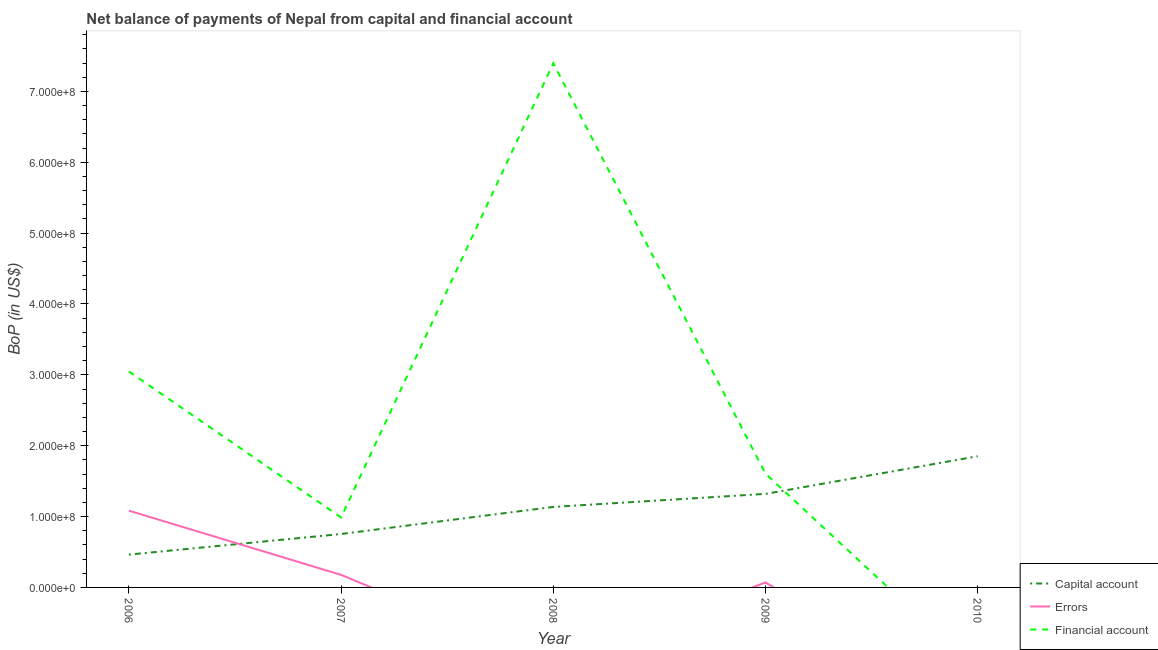What is the amount of errors in 2006?
Your answer should be very brief. 1.08e+08. Across all years, what is the maximum amount of net capital account?
Ensure brevity in your answer.  1.85e+08. Across all years, what is the minimum amount of errors?
Make the answer very short. 0. What is the total amount of net capital account in the graph?
Make the answer very short. 5.52e+08. What is the difference between the amount of financial account in 2006 and that in 2009?
Give a very brief answer. 1.44e+08. What is the difference between the amount of financial account in 2007 and the amount of errors in 2006?
Offer a terse response. -9.59e+06. What is the average amount of financial account per year?
Keep it short and to the point. 2.61e+08. In the year 2009, what is the difference between the amount of net capital account and amount of errors?
Your answer should be very brief. 1.25e+08. In how many years, is the amount of net capital account greater than 280000000 US$?
Offer a terse response. 0. What is the ratio of the amount of financial account in 2006 to that in 2008?
Make the answer very short. 0.41. Is the difference between the amount of financial account in 2006 and 2008 greater than the difference between the amount of net capital account in 2006 and 2008?
Keep it short and to the point. No. What is the difference between the highest and the second highest amount of net capital account?
Your response must be concise. 5.31e+07. What is the difference between the highest and the lowest amount of net capital account?
Provide a succinct answer. 1.39e+08. Is it the case that in every year, the sum of the amount of net capital account and amount of errors is greater than the amount of financial account?
Give a very brief answer. No. Is the amount of net capital account strictly greater than the amount of errors over the years?
Give a very brief answer. No. How many lines are there?
Your answer should be very brief. 3. What is the difference between two consecutive major ticks on the Y-axis?
Offer a very short reply. 1.00e+08. Are the values on the major ticks of Y-axis written in scientific E-notation?
Keep it short and to the point. Yes. Does the graph contain grids?
Offer a very short reply. No. How are the legend labels stacked?
Provide a succinct answer. Vertical. What is the title of the graph?
Your response must be concise. Net balance of payments of Nepal from capital and financial account. Does "Industrial Nitrous Oxide" appear as one of the legend labels in the graph?
Ensure brevity in your answer.  No. What is the label or title of the X-axis?
Offer a very short reply. Year. What is the label or title of the Y-axis?
Provide a succinct answer. BoP (in US$). What is the BoP (in US$) in Capital account in 2006?
Your answer should be compact. 4.63e+07. What is the BoP (in US$) in Errors in 2006?
Ensure brevity in your answer.  1.08e+08. What is the BoP (in US$) in Financial account in 2006?
Your response must be concise. 3.05e+08. What is the BoP (in US$) in Capital account in 2007?
Your response must be concise. 7.54e+07. What is the BoP (in US$) of Errors in 2007?
Offer a terse response. 1.77e+07. What is the BoP (in US$) of Financial account in 2007?
Your answer should be compact. 9.88e+07. What is the BoP (in US$) of Capital account in 2008?
Provide a short and direct response. 1.14e+08. What is the BoP (in US$) of Errors in 2008?
Your answer should be compact. 0. What is the BoP (in US$) in Financial account in 2008?
Make the answer very short. 7.40e+08. What is the BoP (in US$) of Capital account in 2009?
Keep it short and to the point. 1.32e+08. What is the BoP (in US$) in Errors in 2009?
Offer a terse response. 7.03e+06. What is the BoP (in US$) in Financial account in 2009?
Your answer should be very brief. 1.60e+08. What is the BoP (in US$) in Capital account in 2010?
Keep it short and to the point. 1.85e+08. What is the BoP (in US$) in Errors in 2010?
Offer a terse response. 0. What is the BoP (in US$) in Financial account in 2010?
Ensure brevity in your answer.  0. Across all years, what is the maximum BoP (in US$) of Capital account?
Your answer should be very brief. 1.85e+08. Across all years, what is the maximum BoP (in US$) in Errors?
Your answer should be very brief. 1.08e+08. Across all years, what is the maximum BoP (in US$) in Financial account?
Offer a terse response. 7.40e+08. Across all years, what is the minimum BoP (in US$) of Capital account?
Keep it short and to the point. 4.63e+07. Across all years, what is the minimum BoP (in US$) in Financial account?
Your response must be concise. 0. What is the total BoP (in US$) in Capital account in the graph?
Give a very brief answer. 5.52e+08. What is the total BoP (in US$) in Errors in the graph?
Provide a succinct answer. 1.33e+08. What is the total BoP (in US$) of Financial account in the graph?
Your answer should be very brief. 1.30e+09. What is the difference between the BoP (in US$) of Capital account in 2006 and that in 2007?
Provide a short and direct response. -2.91e+07. What is the difference between the BoP (in US$) in Errors in 2006 and that in 2007?
Give a very brief answer. 9.06e+07. What is the difference between the BoP (in US$) in Financial account in 2006 and that in 2007?
Your answer should be compact. 2.06e+08. What is the difference between the BoP (in US$) of Capital account in 2006 and that in 2008?
Your answer should be very brief. -6.73e+07. What is the difference between the BoP (in US$) of Financial account in 2006 and that in 2008?
Your answer should be compact. -4.35e+08. What is the difference between the BoP (in US$) in Capital account in 2006 and that in 2009?
Offer a terse response. -8.57e+07. What is the difference between the BoP (in US$) of Errors in 2006 and that in 2009?
Provide a short and direct response. 1.01e+08. What is the difference between the BoP (in US$) in Financial account in 2006 and that in 2009?
Your answer should be very brief. 1.44e+08. What is the difference between the BoP (in US$) of Capital account in 2006 and that in 2010?
Ensure brevity in your answer.  -1.39e+08. What is the difference between the BoP (in US$) in Capital account in 2007 and that in 2008?
Your response must be concise. -3.82e+07. What is the difference between the BoP (in US$) in Financial account in 2007 and that in 2008?
Offer a very short reply. -6.41e+08. What is the difference between the BoP (in US$) in Capital account in 2007 and that in 2009?
Provide a succinct answer. -5.66e+07. What is the difference between the BoP (in US$) in Errors in 2007 and that in 2009?
Your response must be concise. 1.07e+07. What is the difference between the BoP (in US$) of Financial account in 2007 and that in 2009?
Your answer should be very brief. -6.17e+07. What is the difference between the BoP (in US$) of Capital account in 2007 and that in 2010?
Your answer should be very brief. -1.10e+08. What is the difference between the BoP (in US$) in Capital account in 2008 and that in 2009?
Your answer should be very brief. -1.84e+07. What is the difference between the BoP (in US$) in Financial account in 2008 and that in 2009?
Give a very brief answer. 5.79e+08. What is the difference between the BoP (in US$) in Capital account in 2008 and that in 2010?
Keep it short and to the point. -7.15e+07. What is the difference between the BoP (in US$) in Capital account in 2009 and that in 2010?
Provide a succinct answer. -5.31e+07. What is the difference between the BoP (in US$) of Capital account in 2006 and the BoP (in US$) of Errors in 2007?
Offer a very short reply. 2.86e+07. What is the difference between the BoP (in US$) of Capital account in 2006 and the BoP (in US$) of Financial account in 2007?
Your answer should be very brief. -5.25e+07. What is the difference between the BoP (in US$) of Errors in 2006 and the BoP (in US$) of Financial account in 2007?
Make the answer very short. 9.59e+06. What is the difference between the BoP (in US$) in Capital account in 2006 and the BoP (in US$) in Financial account in 2008?
Give a very brief answer. -6.93e+08. What is the difference between the BoP (in US$) of Errors in 2006 and the BoP (in US$) of Financial account in 2008?
Give a very brief answer. -6.31e+08. What is the difference between the BoP (in US$) of Capital account in 2006 and the BoP (in US$) of Errors in 2009?
Offer a terse response. 3.93e+07. What is the difference between the BoP (in US$) of Capital account in 2006 and the BoP (in US$) of Financial account in 2009?
Ensure brevity in your answer.  -1.14e+08. What is the difference between the BoP (in US$) of Errors in 2006 and the BoP (in US$) of Financial account in 2009?
Provide a succinct answer. -5.21e+07. What is the difference between the BoP (in US$) in Capital account in 2007 and the BoP (in US$) in Financial account in 2008?
Your answer should be compact. -6.64e+08. What is the difference between the BoP (in US$) in Errors in 2007 and the BoP (in US$) in Financial account in 2008?
Provide a short and direct response. -7.22e+08. What is the difference between the BoP (in US$) of Capital account in 2007 and the BoP (in US$) of Errors in 2009?
Your response must be concise. 6.84e+07. What is the difference between the BoP (in US$) of Capital account in 2007 and the BoP (in US$) of Financial account in 2009?
Offer a terse response. -8.51e+07. What is the difference between the BoP (in US$) in Errors in 2007 and the BoP (in US$) in Financial account in 2009?
Ensure brevity in your answer.  -1.43e+08. What is the difference between the BoP (in US$) in Capital account in 2008 and the BoP (in US$) in Errors in 2009?
Your answer should be very brief. 1.07e+08. What is the difference between the BoP (in US$) in Capital account in 2008 and the BoP (in US$) in Financial account in 2009?
Ensure brevity in your answer.  -4.69e+07. What is the average BoP (in US$) in Capital account per year?
Offer a very short reply. 1.10e+08. What is the average BoP (in US$) in Errors per year?
Your answer should be very brief. 2.66e+07. What is the average BoP (in US$) in Financial account per year?
Give a very brief answer. 2.61e+08. In the year 2006, what is the difference between the BoP (in US$) of Capital account and BoP (in US$) of Errors?
Provide a short and direct response. -6.20e+07. In the year 2006, what is the difference between the BoP (in US$) of Capital account and BoP (in US$) of Financial account?
Your answer should be very brief. -2.58e+08. In the year 2006, what is the difference between the BoP (in US$) in Errors and BoP (in US$) in Financial account?
Provide a short and direct response. -1.96e+08. In the year 2007, what is the difference between the BoP (in US$) in Capital account and BoP (in US$) in Errors?
Give a very brief answer. 5.77e+07. In the year 2007, what is the difference between the BoP (in US$) in Capital account and BoP (in US$) in Financial account?
Offer a very short reply. -2.34e+07. In the year 2007, what is the difference between the BoP (in US$) in Errors and BoP (in US$) in Financial account?
Provide a short and direct response. -8.10e+07. In the year 2008, what is the difference between the BoP (in US$) in Capital account and BoP (in US$) in Financial account?
Make the answer very short. -6.26e+08. In the year 2009, what is the difference between the BoP (in US$) in Capital account and BoP (in US$) in Errors?
Your response must be concise. 1.25e+08. In the year 2009, what is the difference between the BoP (in US$) of Capital account and BoP (in US$) of Financial account?
Provide a short and direct response. -2.84e+07. In the year 2009, what is the difference between the BoP (in US$) of Errors and BoP (in US$) of Financial account?
Your response must be concise. -1.53e+08. What is the ratio of the BoP (in US$) of Capital account in 2006 to that in 2007?
Give a very brief answer. 0.61. What is the ratio of the BoP (in US$) of Errors in 2006 to that in 2007?
Give a very brief answer. 6.11. What is the ratio of the BoP (in US$) in Financial account in 2006 to that in 2007?
Offer a very short reply. 3.09. What is the ratio of the BoP (in US$) in Capital account in 2006 to that in 2008?
Keep it short and to the point. 0.41. What is the ratio of the BoP (in US$) of Financial account in 2006 to that in 2008?
Your answer should be very brief. 0.41. What is the ratio of the BoP (in US$) of Capital account in 2006 to that in 2009?
Your answer should be compact. 0.35. What is the ratio of the BoP (in US$) in Errors in 2006 to that in 2009?
Offer a very short reply. 15.41. What is the ratio of the BoP (in US$) of Financial account in 2006 to that in 2009?
Provide a succinct answer. 1.9. What is the ratio of the BoP (in US$) in Capital account in 2006 to that in 2010?
Provide a short and direct response. 0.25. What is the ratio of the BoP (in US$) of Capital account in 2007 to that in 2008?
Ensure brevity in your answer.  0.66. What is the ratio of the BoP (in US$) in Financial account in 2007 to that in 2008?
Give a very brief answer. 0.13. What is the ratio of the BoP (in US$) of Capital account in 2007 to that in 2009?
Give a very brief answer. 0.57. What is the ratio of the BoP (in US$) of Errors in 2007 to that in 2009?
Offer a very short reply. 2.52. What is the ratio of the BoP (in US$) of Financial account in 2007 to that in 2009?
Ensure brevity in your answer.  0.62. What is the ratio of the BoP (in US$) in Capital account in 2007 to that in 2010?
Provide a succinct answer. 0.41. What is the ratio of the BoP (in US$) of Capital account in 2008 to that in 2009?
Make the answer very short. 0.86. What is the ratio of the BoP (in US$) of Financial account in 2008 to that in 2009?
Ensure brevity in your answer.  4.61. What is the ratio of the BoP (in US$) in Capital account in 2008 to that in 2010?
Keep it short and to the point. 0.61. What is the ratio of the BoP (in US$) in Capital account in 2009 to that in 2010?
Give a very brief answer. 0.71. What is the difference between the highest and the second highest BoP (in US$) of Capital account?
Your response must be concise. 5.31e+07. What is the difference between the highest and the second highest BoP (in US$) in Errors?
Ensure brevity in your answer.  9.06e+07. What is the difference between the highest and the second highest BoP (in US$) of Financial account?
Provide a short and direct response. 4.35e+08. What is the difference between the highest and the lowest BoP (in US$) in Capital account?
Your response must be concise. 1.39e+08. What is the difference between the highest and the lowest BoP (in US$) of Errors?
Your answer should be compact. 1.08e+08. What is the difference between the highest and the lowest BoP (in US$) in Financial account?
Ensure brevity in your answer.  7.40e+08. 